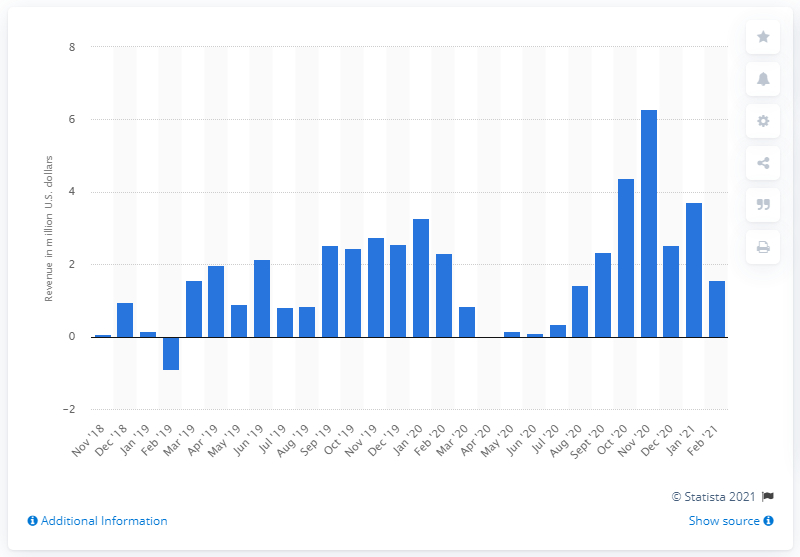Highlight a few significant elements in this photo. In February 2021, Rhode Island generated approximately $1.56 million from sports betting. 